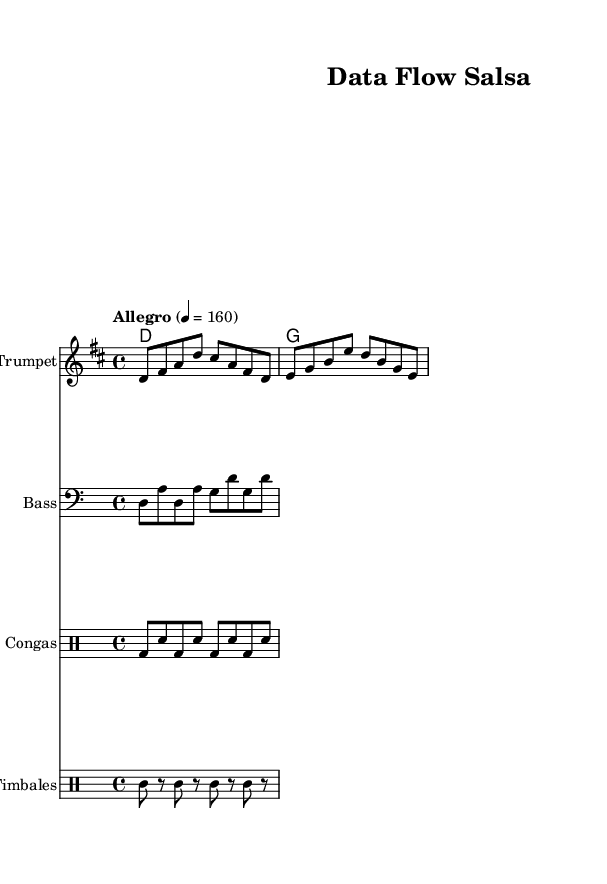What is the key signature of this music? The key signature has two sharps (F# and C#), indicating that it is in D major. This is deduced from the global settings at the beginning of the code.
Answer: D major What is the time signature of this music? The time signature is indicated as 4/4 in the global settings, which means there are four beats per measure and the quarter note receives one beat.
Answer: 4/4 What is the tempo marking for this piece? The tempo marking is Allegro, with a specific metronome marking of 160 beats per minute. This means the music should be played in a lively and fast pace.
Answer: Allegro 4 = 160 What instruments are featured in this piece? The sheet music includes a Trumpet for the melody, a Bass for support, and two drum parts for rhythm: Congas and Timbales. These are specified in the score sections of the code.
Answer: Trumpet, Bass, Congas, Timbales What type of rhythm is primarily used in the rhythm section? The rhythm section features a consistent pattern of bass drum and snare for the Congas and a pattern of high and low hits for Timbales, typical for Latin music styles, creating a syncopated upbeat rhythm.
Answer: Upbeat salsa 